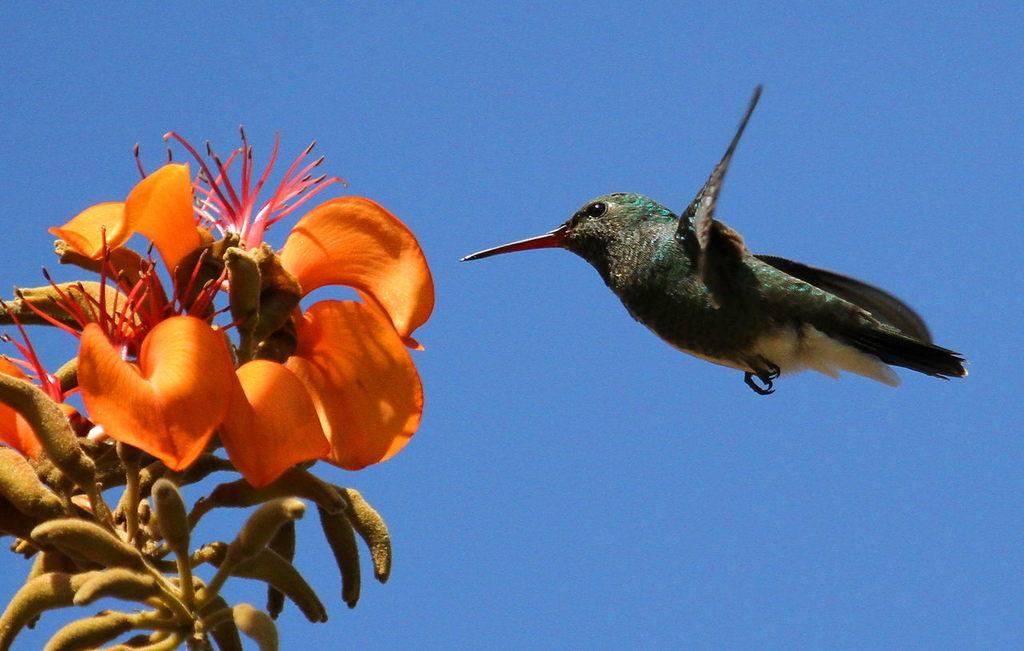Where was the picture taken? The picture was clicked outside. What can be seen flying in the air on the right side of the image? There is a bird flying in the air on the right side of the image. What type of vegetation is on the left side of the image? There are flowers on the left side of the image. What is visible in the background of the image? The sky is visible in the background of the image. What type of cheese is being served during the meal in the image? There is no meal or cheese present in the image; it features a bird flying and flowers on the left side. What type of playground equipment can be seen in the image? There is no playground equipment present in the image; it features a bird flying and flowers on the left side. 